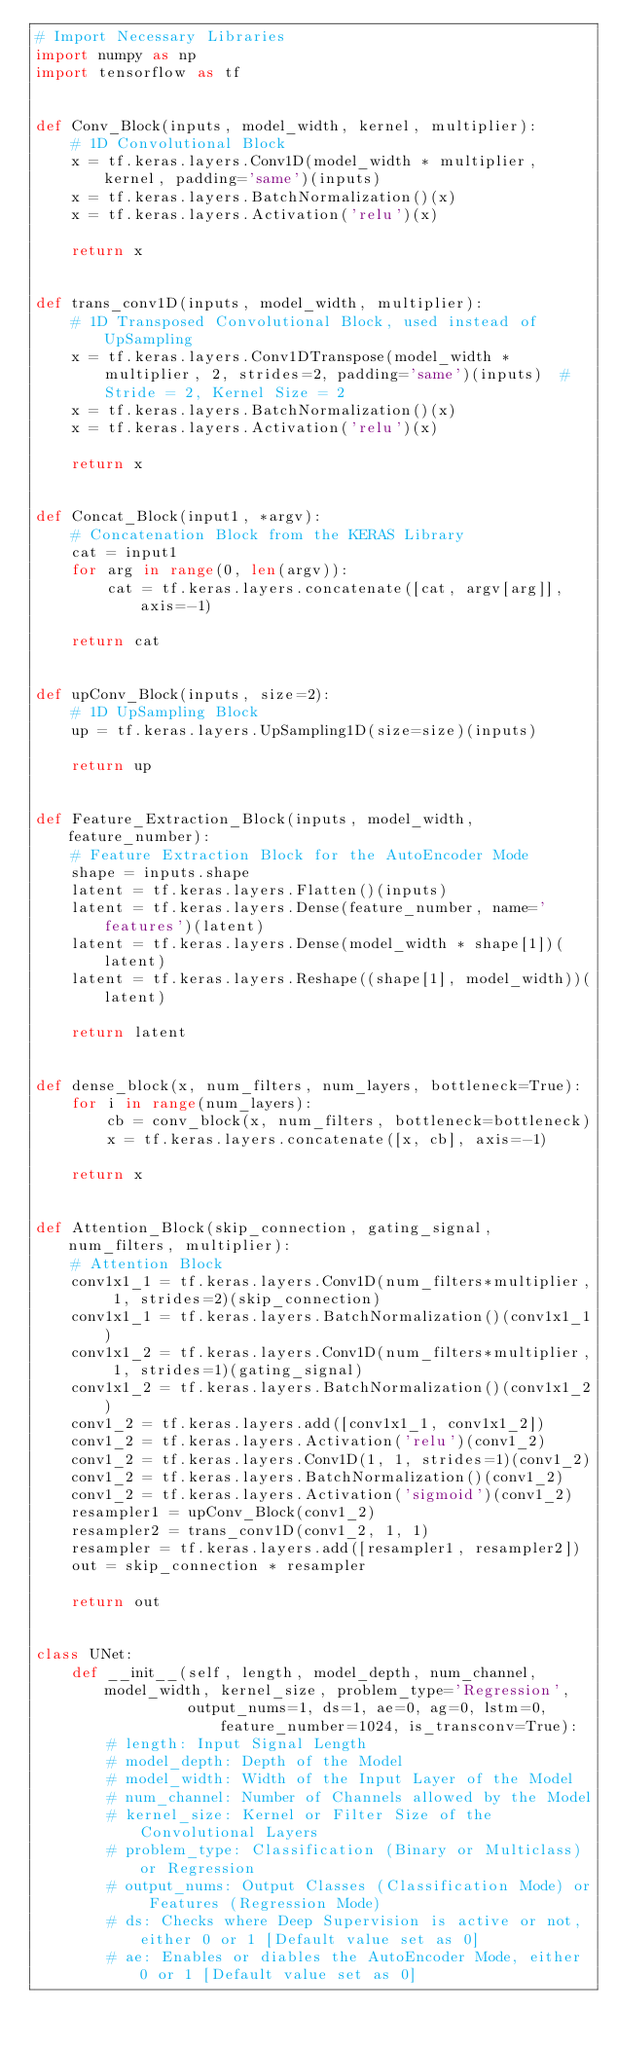Convert code to text. <code><loc_0><loc_0><loc_500><loc_500><_Python_># Import Necessary Libraries
import numpy as np
import tensorflow as tf


def Conv_Block(inputs, model_width, kernel, multiplier):
    # 1D Convolutional Block
    x = tf.keras.layers.Conv1D(model_width * multiplier, kernel, padding='same')(inputs)
    x = tf.keras.layers.BatchNormalization()(x)
    x = tf.keras.layers.Activation('relu')(x)

    return x


def trans_conv1D(inputs, model_width, multiplier):
    # 1D Transposed Convolutional Block, used instead of UpSampling
    x = tf.keras.layers.Conv1DTranspose(model_width * multiplier, 2, strides=2, padding='same')(inputs)  # Stride = 2, Kernel Size = 2
    x = tf.keras.layers.BatchNormalization()(x)
    x = tf.keras.layers.Activation('relu')(x)

    return x


def Concat_Block(input1, *argv):
    # Concatenation Block from the KERAS Library
    cat = input1
    for arg in range(0, len(argv)):
        cat = tf.keras.layers.concatenate([cat, argv[arg]], axis=-1)

    return cat


def upConv_Block(inputs, size=2):
    # 1D UpSampling Block
    up = tf.keras.layers.UpSampling1D(size=size)(inputs)

    return up


def Feature_Extraction_Block(inputs, model_width, feature_number):
    # Feature Extraction Block for the AutoEncoder Mode
    shape = inputs.shape
    latent = tf.keras.layers.Flatten()(inputs)
    latent = tf.keras.layers.Dense(feature_number, name='features')(latent)
    latent = tf.keras.layers.Dense(model_width * shape[1])(latent)
    latent = tf.keras.layers.Reshape((shape[1], model_width))(latent)

    return latent


def dense_block(x, num_filters, num_layers, bottleneck=True):
    for i in range(num_layers):
        cb = conv_block(x, num_filters, bottleneck=bottleneck)
        x = tf.keras.layers.concatenate([x, cb], axis=-1)

    return x


def Attention_Block(skip_connection, gating_signal, num_filters, multiplier):
    # Attention Block
    conv1x1_1 = tf.keras.layers.Conv1D(num_filters*multiplier, 1, strides=2)(skip_connection)
    conv1x1_1 = tf.keras.layers.BatchNormalization()(conv1x1_1)
    conv1x1_2 = tf.keras.layers.Conv1D(num_filters*multiplier, 1, strides=1)(gating_signal)
    conv1x1_2 = tf.keras.layers.BatchNormalization()(conv1x1_2)
    conv1_2 = tf.keras.layers.add([conv1x1_1, conv1x1_2])
    conv1_2 = tf.keras.layers.Activation('relu')(conv1_2)
    conv1_2 = tf.keras.layers.Conv1D(1, 1, strides=1)(conv1_2)
    conv1_2 = tf.keras.layers.BatchNormalization()(conv1_2)
    conv1_2 = tf.keras.layers.Activation('sigmoid')(conv1_2)
    resampler1 = upConv_Block(conv1_2)
    resampler2 = trans_conv1D(conv1_2, 1, 1)
    resampler = tf.keras.layers.add([resampler1, resampler2])
    out = skip_connection * resampler

    return out


class UNet:
    def __init__(self, length, model_depth, num_channel, model_width, kernel_size, problem_type='Regression',
                 output_nums=1, ds=1, ae=0, ag=0, lstm=0, feature_number=1024, is_transconv=True):
        # length: Input Signal Length
        # model_depth: Depth of the Model
        # model_width: Width of the Input Layer of the Model
        # num_channel: Number of Channels allowed by the Model
        # kernel_size: Kernel or Filter Size of the Convolutional Layers
        # problem_type: Classification (Binary or Multiclass) or Regression
        # output_nums: Output Classes (Classification Mode) or Features (Regression Mode)
        # ds: Checks where Deep Supervision is active or not, either 0 or 1 [Default value set as 0]
        # ae: Enables or diables the AutoEncoder Mode, either 0 or 1 [Default value set as 0]</code> 